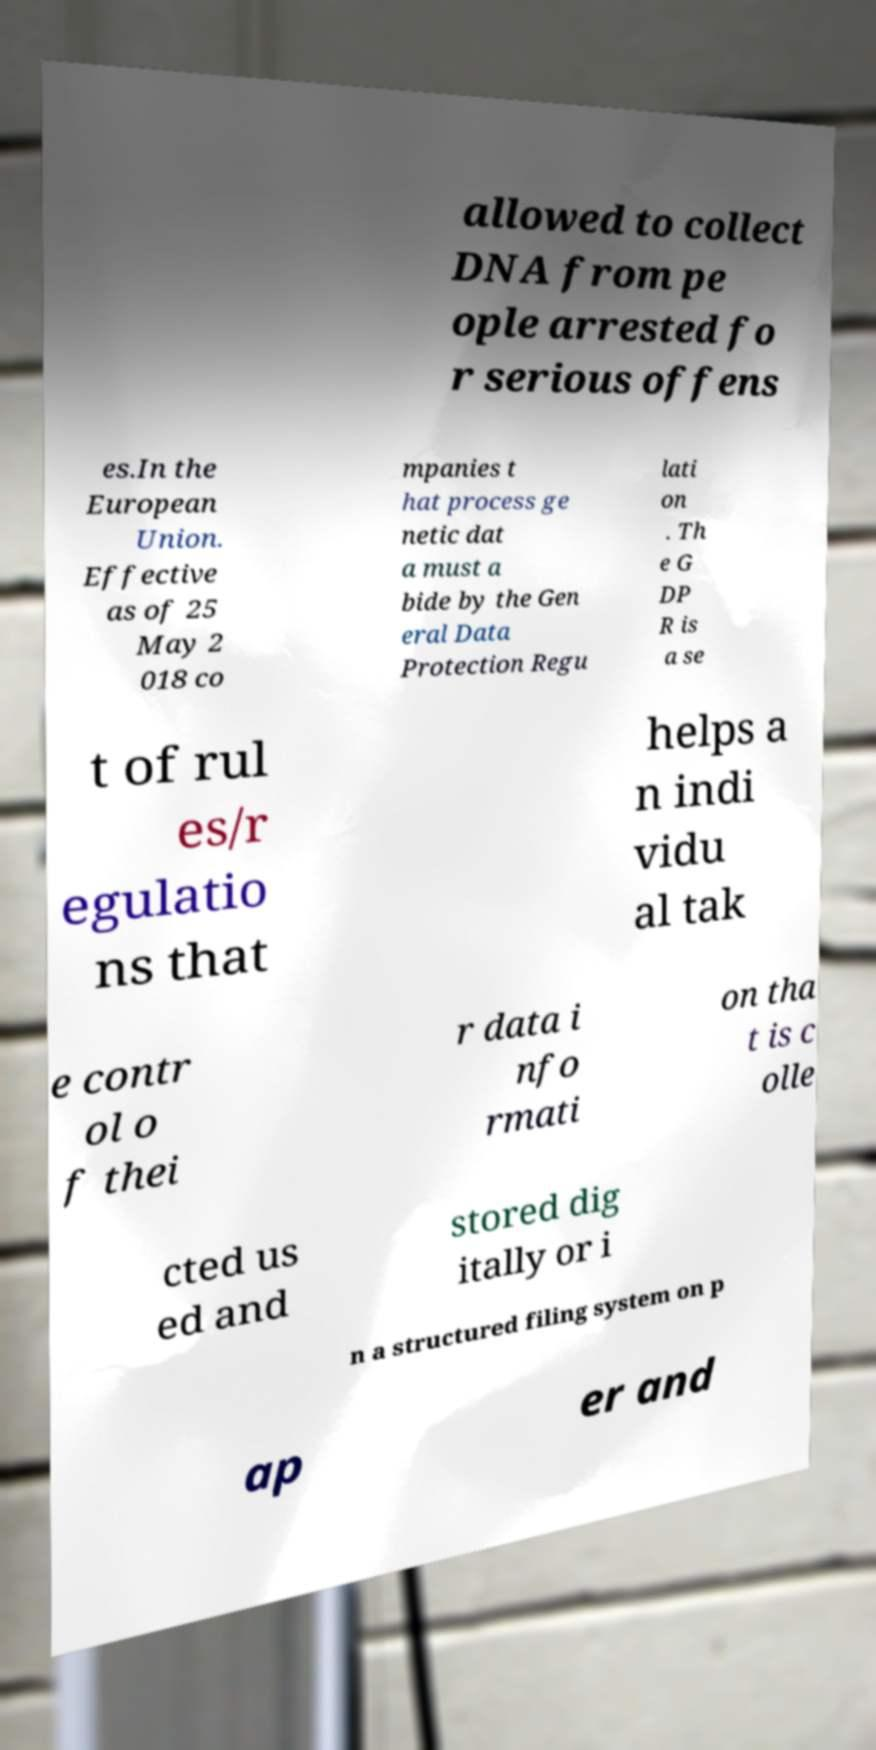Can you read and provide the text displayed in the image?This photo seems to have some interesting text. Can you extract and type it out for me? allowed to collect DNA from pe ople arrested fo r serious offens es.In the European Union. Effective as of 25 May 2 018 co mpanies t hat process ge netic dat a must a bide by the Gen eral Data Protection Regu lati on . Th e G DP R is a se t of rul es/r egulatio ns that helps a n indi vidu al tak e contr ol o f thei r data i nfo rmati on tha t is c olle cted us ed and stored dig itally or i n a structured filing system on p ap er and 